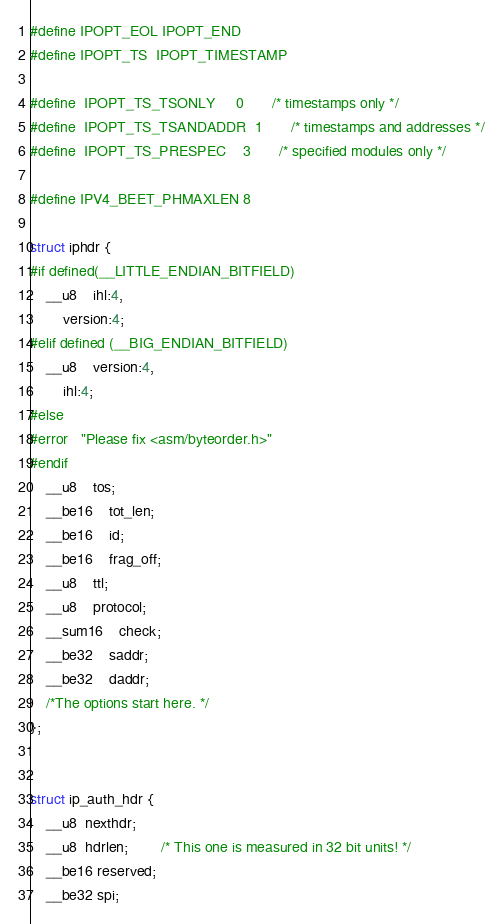<code> <loc_0><loc_0><loc_500><loc_500><_C_>#define IPOPT_EOL IPOPT_END
#define IPOPT_TS  IPOPT_TIMESTAMP

#define	IPOPT_TS_TSONLY		0		/* timestamps only */
#define	IPOPT_TS_TSANDADDR	1		/* timestamps and addresses */
#define	IPOPT_TS_PRESPEC	3		/* specified modules only */

#define IPV4_BEET_PHMAXLEN 8

struct iphdr {
#if defined(__LITTLE_ENDIAN_BITFIELD)
	__u8	ihl:4,
		version:4;
#elif defined (__BIG_ENDIAN_BITFIELD)
	__u8	version:4,
  		ihl:4;
#else
#error	"Please fix <asm/byteorder.h>"
#endif
	__u8	tos;
	__be16	tot_len;
	__be16	id;
	__be16	frag_off;
	__u8	ttl;
	__u8	protocol;
	__sum16	check;
	__be32	saddr;
	__be32	daddr;
	/*The options start here. */
};


struct ip_auth_hdr {
	__u8  nexthdr;
	__u8  hdrlen;		/* This one is measured in 32 bit units! */
	__be16 reserved;
	__be32 spi;</code> 